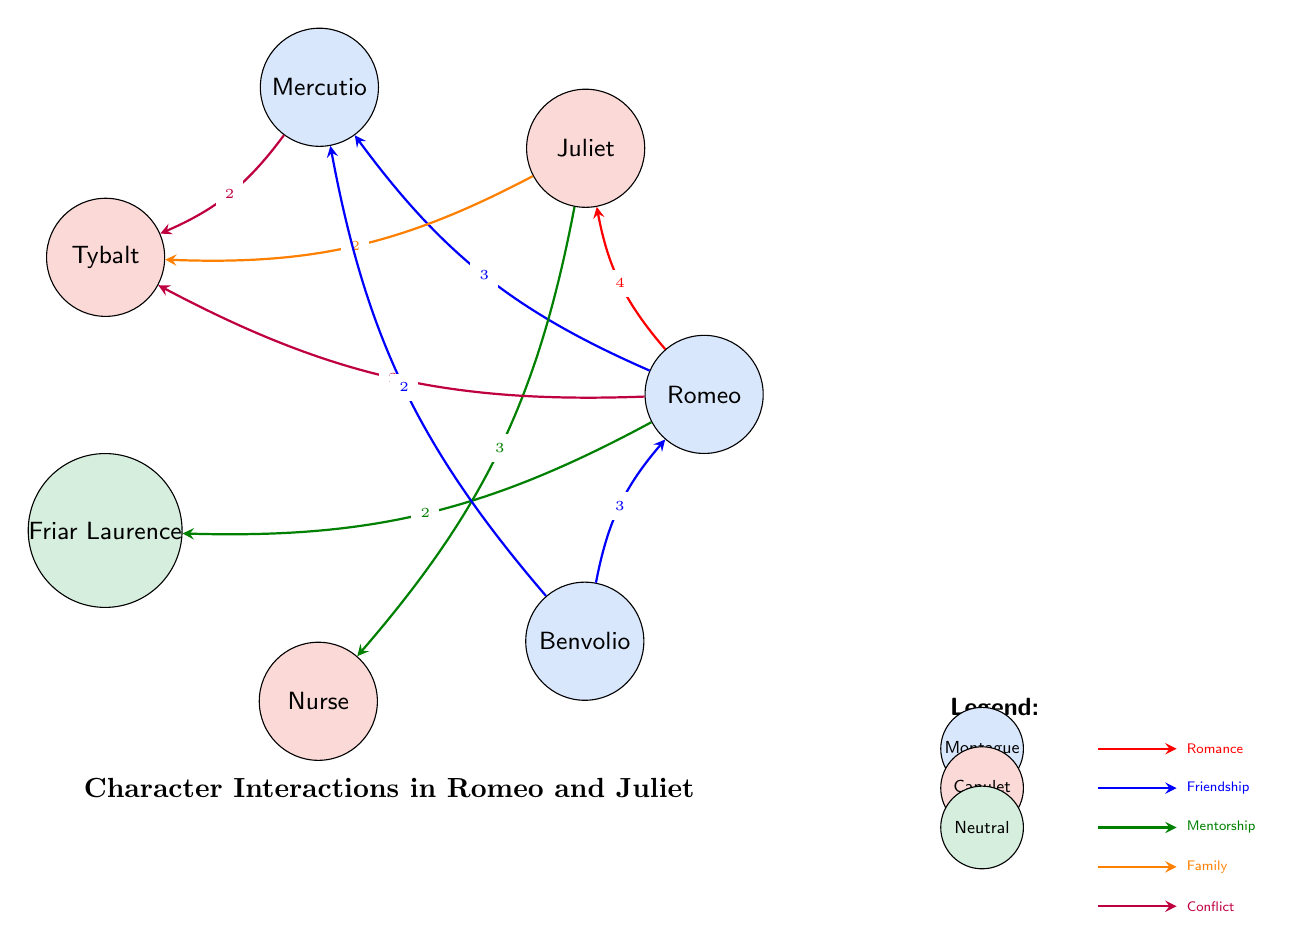What are the total number of characters represented in the diagram? By counting the nodes listed in the diagram, we find there are seven characters: Romeo, Juliet, Mercutio, Tybalt, Friar Laurence, Nurse, and Benvolio.
Answer: 7 Which type of relationship exists between Romeo and Juliet? The relationship between Romeo and Juliet is labeled as "Romance" in the diagram, with an interaction value of 4 indicating the frequency of this interaction.
Answer: Romance How many connections does Benvolio have in the diagram? Benvolio has connections with two characters, namely Romeo and Mercutio. Counting those lines shows he is connected to two characters.
Answer: 2 What character has the highest frequency of interactions? By examining the interaction values, Romeo has the highest interaction value with Juliet (4), indicating he is the most connected character overall in the diagram.
Answer: Romeo How many conflict interactions are represented in the diagram? There are two connections marked as "Conflict" in the diagram, specifically between Mercutio and Tybalt, and between Romeo and Tybalt.
Answer: 2 Which character has a mentorship role towards Juliet? The diagram indicates that the Nurse has a mentorship relationship with Juliet, as denoted by the connection line of type "Mentorship" with a value of 3.
Answer: Nurse What is the interaction value between Mercutio and Tybalt? The diagram shows a conflict interaction between Mercutio and Tybalt with a specific interaction value of 2, indicating the frequency of this relationship.
Answer: 2 Which character group does Friar Laurence belong to? Friar Laurence is categorized as "Neutral" in the diagram, which indicates that he does not belong to either the Montague or Capulet families.
Answer: Neutral 